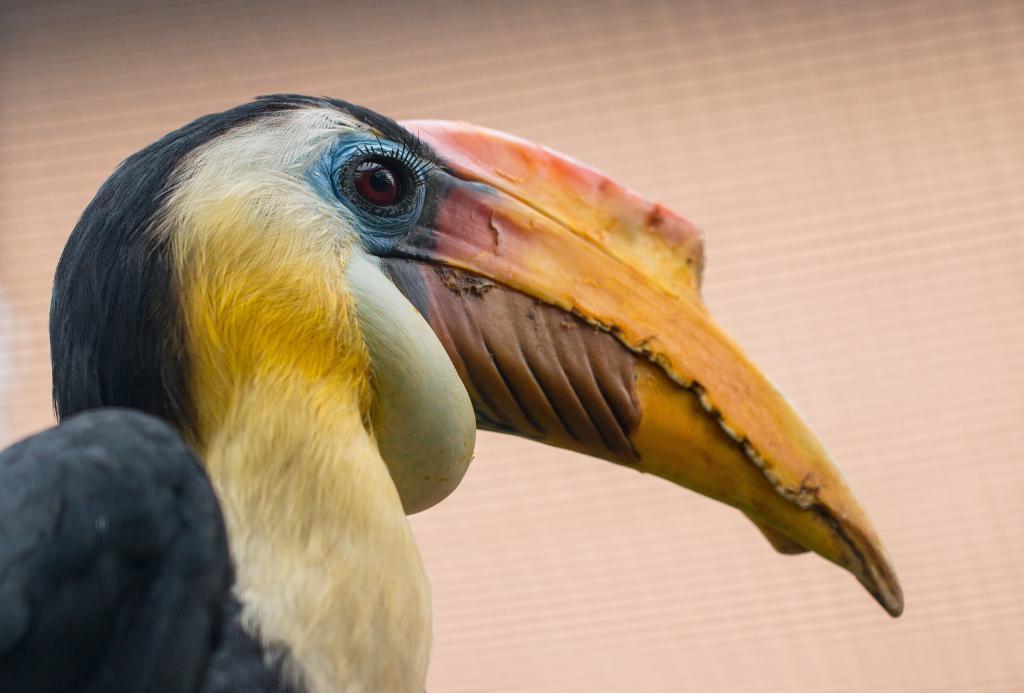In one or two sentences, can you explain what this image depicts? In this image I can see the bird which is in black, yellow, brown, blue and cream color. And there is a brown background. 